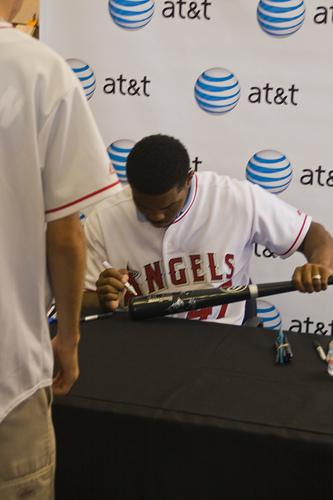What is the seated man's profession? Please explain your reasoning. athlete. The man is wearing a professional sport team jersey. 